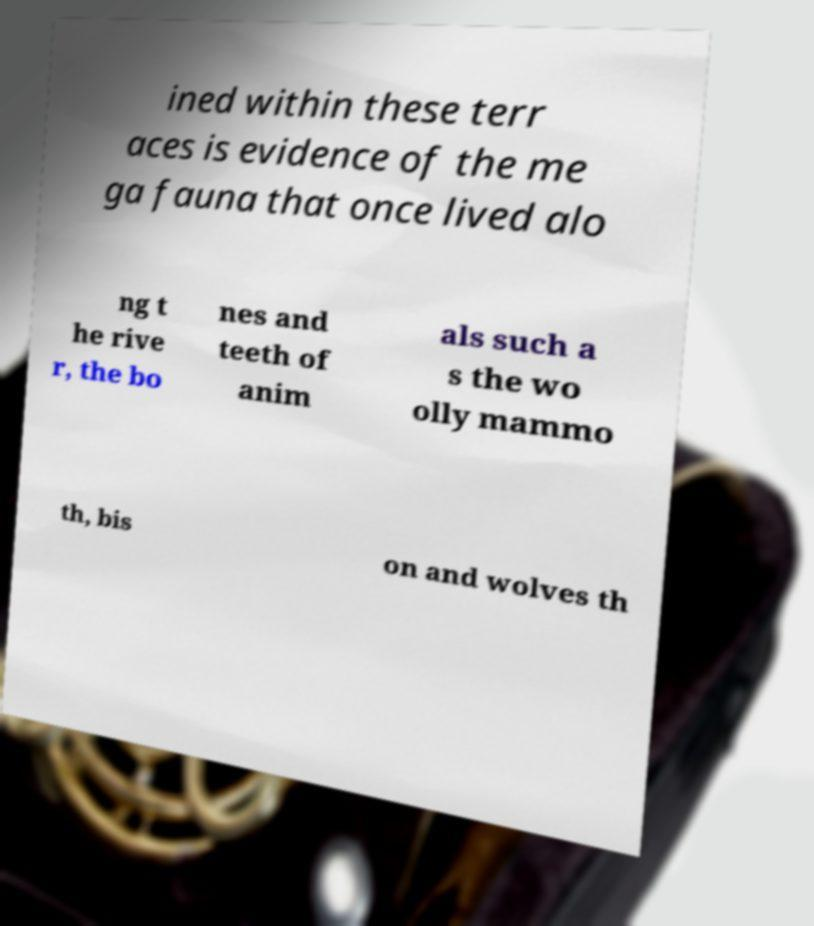Can you read and provide the text displayed in the image?This photo seems to have some interesting text. Can you extract and type it out for me? ined within these terr aces is evidence of the me ga fauna that once lived alo ng t he rive r, the bo nes and teeth of anim als such a s the wo olly mammo th, bis on and wolves th 